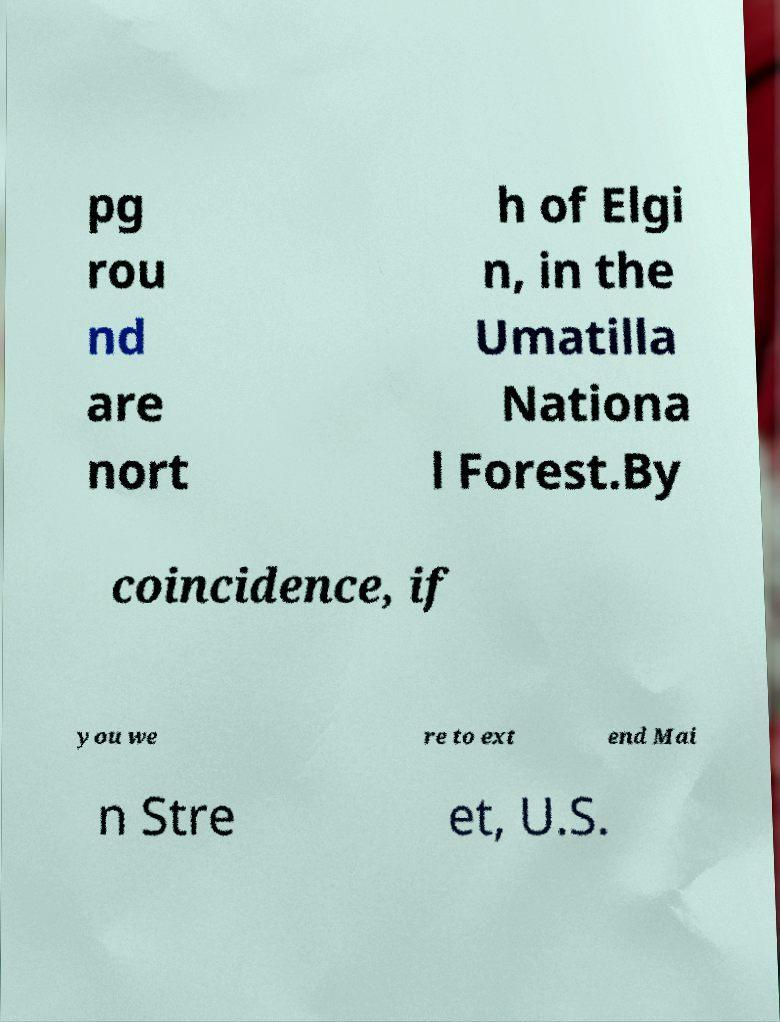What messages or text are displayed in this image? I need them in a readable, typed format. pg rou nd are nort h of Elgi n, in the Umatilla Nationa l Forest.By coincidence, if you we re to ext end Mai n Stre et, U.S. 